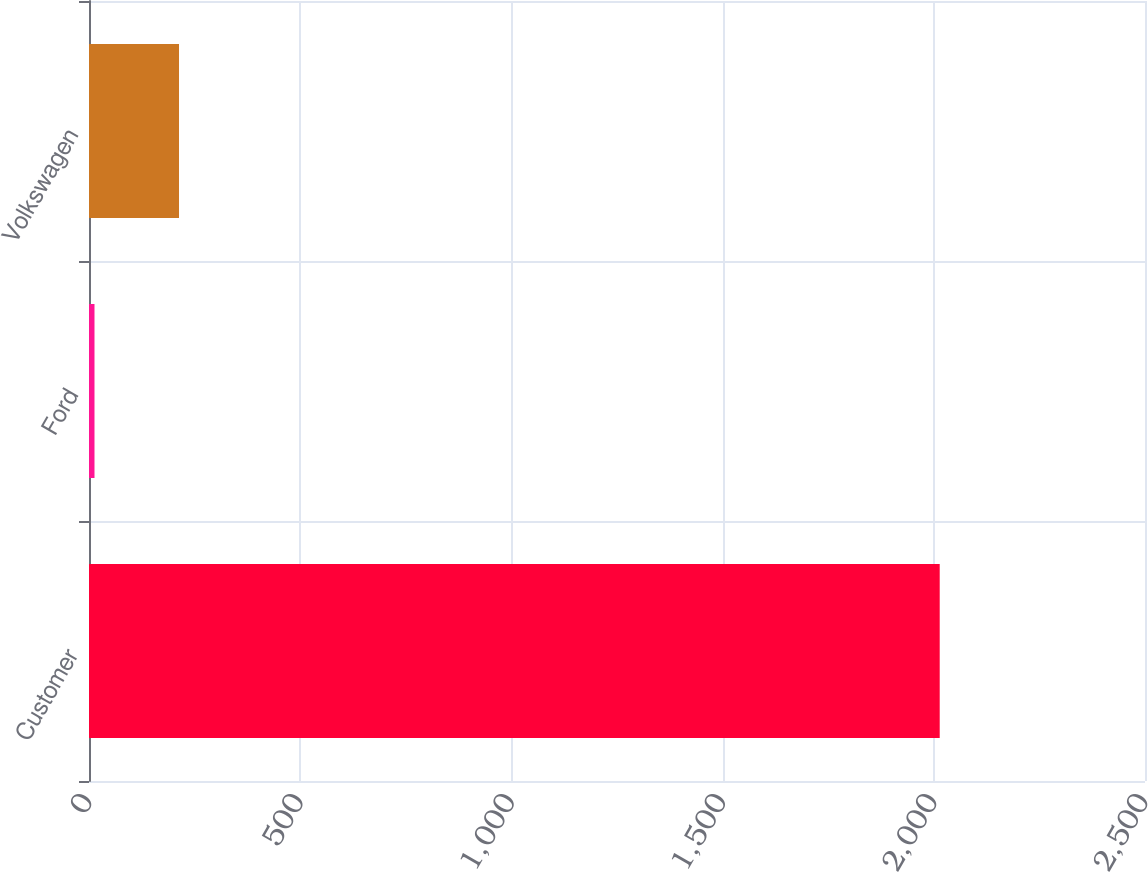Convert chart. <chart><loc_0><loc_0><loc_500><loc_500><bar_chart><fcel>Customer<fcel>Ford<fcel>Volkswagen<nl><fcel>2014<fcel>13<fcel>213.1<nl></chart> 